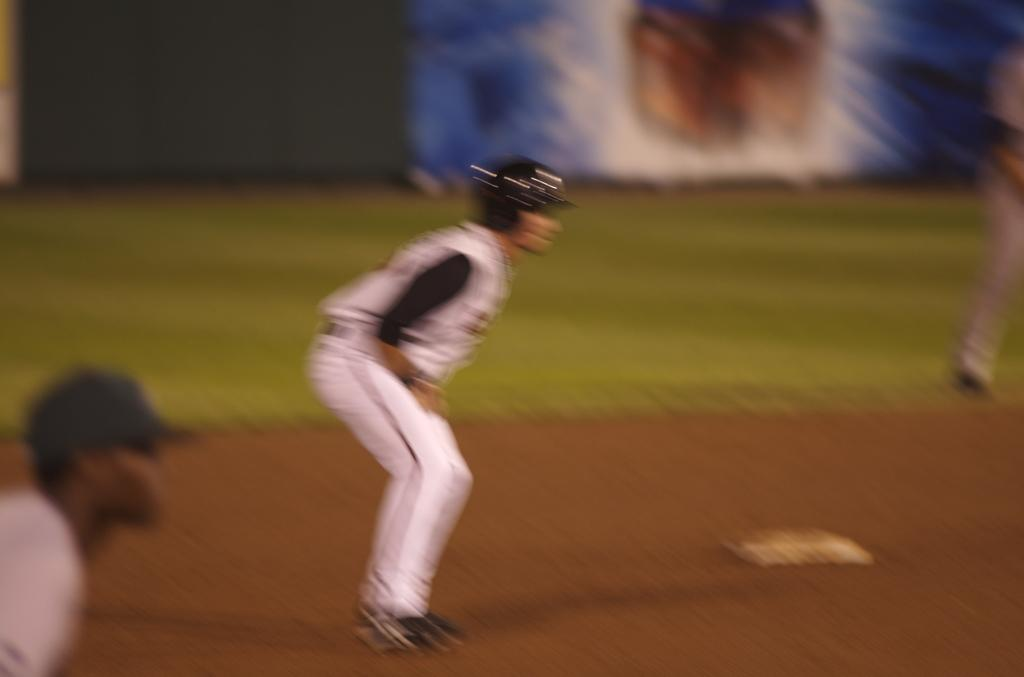What is the primary surface visible in the image? There is a ground in the image. How many men are standing on the ground? There are three men standing on the ground. Can you describe the quality of the image? The image is blurred. What type of notebook is being used by the men in the image? There is no notebook present in the image; it only shows three men standing on the ground. How many boxes can be seen stacked on the ground in the image? There are no boxes present in the image; it only shows three men standing on the ground. 